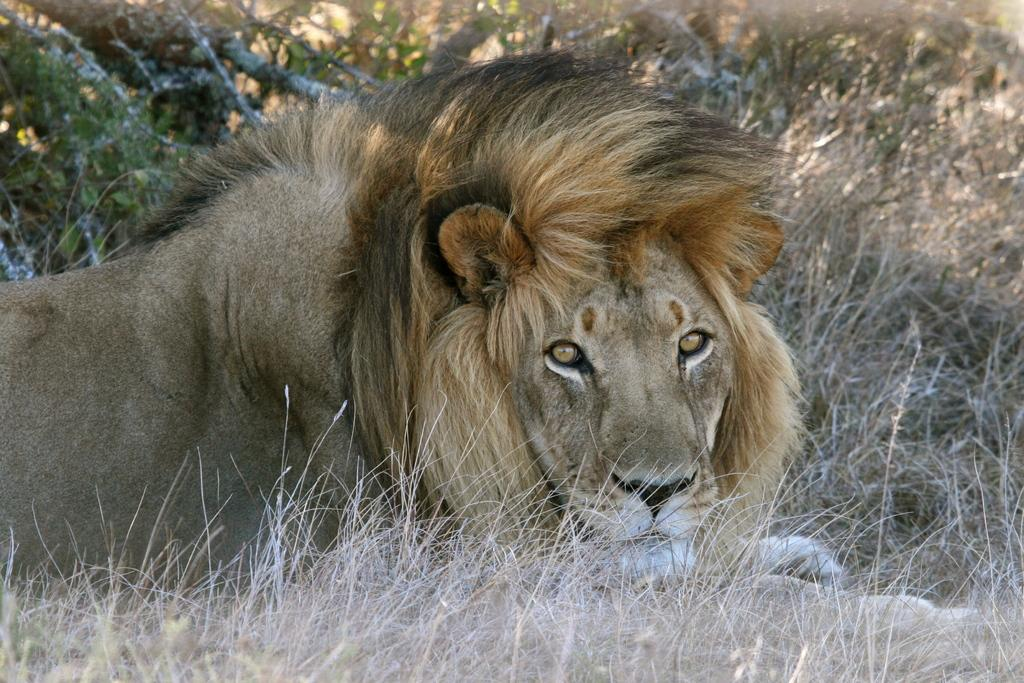What animal is the main subject of the picture? There is a lion in the picture. What type of terrain is visible at the bottom of the picture? There is grass at the bottom of the picture. What can be seen in the background of the picture? There are plants visible in the background of the picture. What type of education is the lion pursuing in the picture? There is no indication in the image that the lion is pursuing any type of education. Can you see a comb in the picture? There is no comb present in the image. 